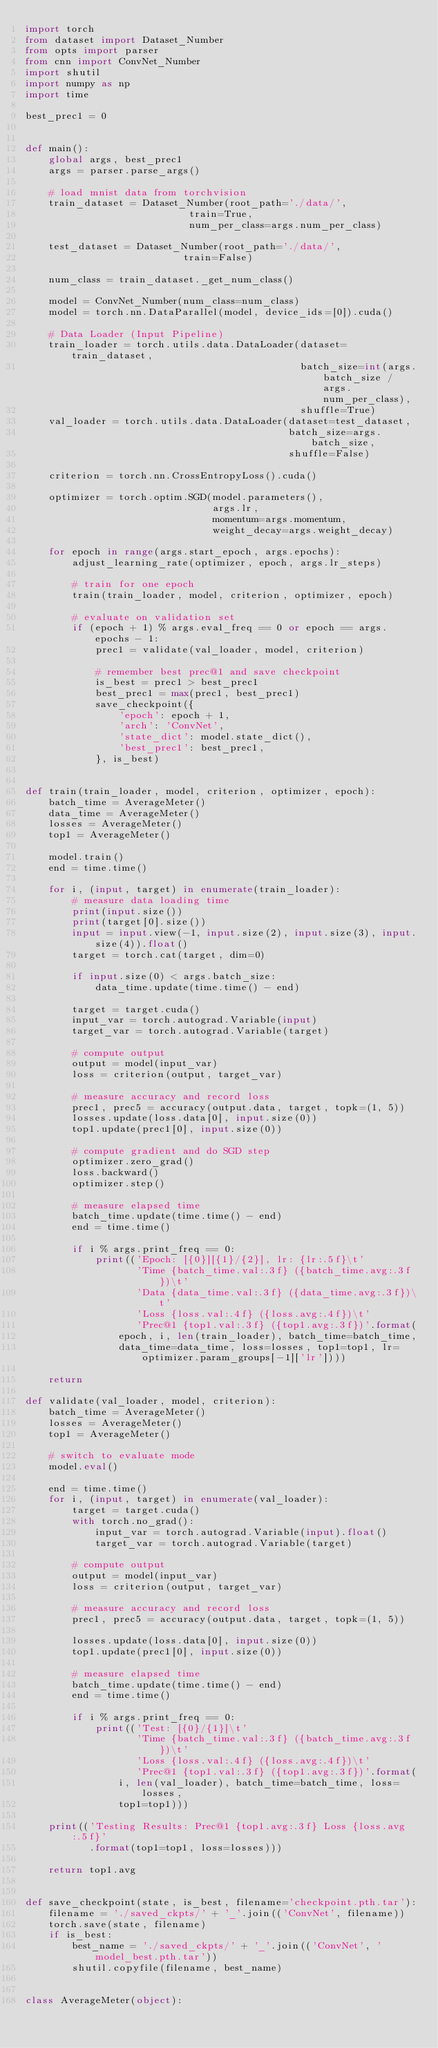<code> <loc_0><loc_0><loc_500><loc_500><_Python_>import torch
from dataset import Dataset_Number
from opts import parser
from cnn import ConvNet_Number
import shutil
import numpy as np
import time

best_prec1 = 0


def main():
    global args, best_prec1
    args = parser.parse_args()

    # load mnist data from torchvision
    train_dataset = Dataset_Number(root_path='./data/',
                            train=True,
                            num_per_class=args.num_per_class)

    test_dataset = Dataset_Number(root_path='./data/',
                           train=False)

    num_class = train_dataset._get_num_class()

    model = ConvNet_Number(num_class=num_class)
    model = torch.nn.DataParallel(model, device_ids=[0]).cuda()

    # Data Loader (Input Pipeline)
    train_loader = torch.utils.data.DataLoader(dataset=train_dataset,
                                               batch_size=int(args.batch_size / args.num_per_class),
                                               shuffle=True)
    val_loader = torch.utils.data.DataLoader(dataset=test_dataset,
                                             batch_size=args.batch_size,
                                             shuffle=False)

    criterion = torch.nn.CrossEntropyLoss().cuda()

    optimizer = torch.optim.SGD(model.parameters(),
                                args.lr,
                                momentum=args.momentum,
                                weight_decay=args.weight_decay)

    for epoch in range(args.start_epoch, args.epochs):
        adjust_learning_rate(optimizer, epoch, args.lr_steps)

        # train for one epoch
        train(train_loader, model, criterion, optimizer, epoch)

        # evaluate on validation set
        if (epoch + 1) % args.eval_freq == 0 or epoch == args.epochs - 1:
            prec1 = validate(val_loader, model, criterion)

            # remember best prec@1 and save checkpoint
            is_best = prec1 > best_prec1
            best_prec1 = max(prec1, best_prec1)
            save_checkpoint({
                'epoch': epoch + 1,
                'arch': 'ConvNet',
                'state_dict': model.state_dict(),
                'best_prec1': best_prec1,
            }, is_best)


def train(train_loader, model, criterion, optimizer, epoch):
    batch_time = AverageMeter()
    data_time = AverageMeter()
    losses = AverageMeter()
    top1 = AverageMeter()

    model.train()
    end = time.time()

    for i, (input, target) in enumerate(train_loader):
        # measure data loading time
        print(input.size())
        print(target[0].size())
        input = input.view(-1, input.size(2), input.size(3), input.size(4)).float()
        target = torch.cat(target, dim=0)

        if input.size(0) < args.batch_size:
            data_time.update(time.time() - end)

        target = target.cuda()
        input_var = torch.autograd.Variable(input)
        target_var = torch.autograd.Variable(target)

        # compute output
        output = model(input_var)
        loss = criterion(output, target_var)

        # measure accuracy and record loss
        prec1, prec5 = accuracy(output.data, target, topk=(1, 5))
        losses.update(loss.data[0], input.size(0))
        top1.update(prec1[0], input.size(0))

        # compute gradient and do SGD step
        optimizer.zero_grad()
        loss.backward()
        optimizer.step()

        # measure elapsed time
        batch_time.update(time.time() - end)
        end = time.time()

        if i % args.print_freq == 0:
            print(('Epoch: [{0}][{1}/{2}], lr: {lr:.5f}\t'
                   'Time {batch_time.val:.3f} ({batch_time.avg:.3f})\t'
                   'Data {data_time.val:.3f} ({data_time.avg:.3f})\t'
                   'Loss {loss.val:.4f} ({loss.avg:.4f})\t'
                   'Prec@1 {top1.val:.3f} ({top1.avg:.3f})'.format(
                epoch, i, len(train_loader), batch_time=batch_time,
                data_time=data_time, loss=losses, top1=top1, lr=optimizer.param_groups[-1]['lr'])))

    return

def validate(val_loader, model, criterion):
    batch_time = AverageMeter()
    losses = AverageMeter()
    top1 = AverageMeter()

    # switch to evaluate mode
    model.eval()

    end = time.time()
    for i, (input, target) in enumerate(val_loader):
        target = target.cuda()
        with torch.no_grad():
            input_var = torch.autograd.Variable(input).float()
            target_var = torch.autograd.Variable(target)

        # compute output
        output = model(input_var)
        loss = criterion(output, target_var)

        # measure accuracy and record loss
        prec1, prec5 = accuracy(output.data, target, topk=(1, 5))

        losses.update(loss.data[0], input.size(0))
        top1.update(prec1[0], input.size(0))

        # measure elapsed time
        batch_time.update(time.time() - end)
        end = time.time()

        if i % args.print_freq == 0:
            print(('Test: [{0}/{1}]\t'
                   'Time {batch_time.val:.3f} ({batch_time.avg:.3f})\t'
                   'Loss {loss.val:.4f} ({loss.avg:.4f})\t'
                   'Prec@1 {top1.val:.3f} ({top1.avg:.3f})'.format(
                i, len(val_loader), batch_time=batch_time, loss=losses,
                top1=top1)))

    print(('Testing Results: Prec@1 {top1.avg:.3f} Loss {loss.avg:.5f}'
           .format(top1=top1, loss=losses)))

    return top1.avg


def save_checkpoint(state, is_best, filename='checkpoint.pth.tar'):
    filename = './saved_ckpts/' + '_'.join(('ConvNet', filename))
    torch.save(state, filename)
    if is_best:
        best_name = './saved_ckpts/' + '_'.join(('ConvNet', 'model_best.pth.tar'))
        shutil.copyfile(filename, best_name)


class AverageMeter(object):</code> 